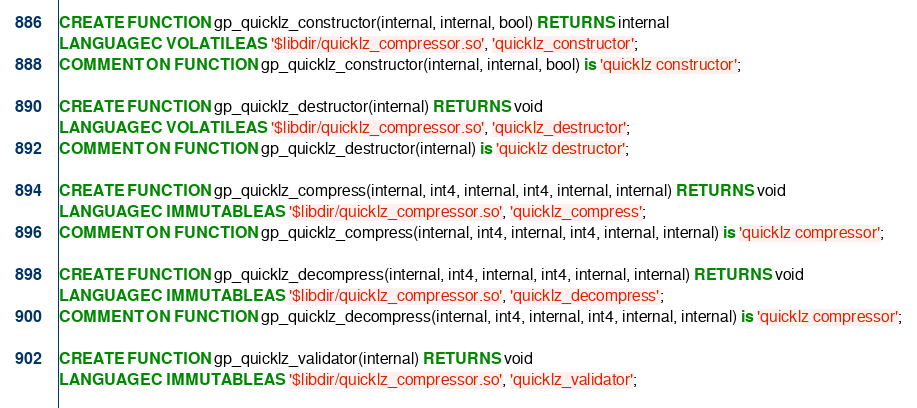Convert code to text. <code><loc_0><loc_0><loc_500><loc_500><_SQL_>CREATE FUNCTION gp_quicklz_constructor(internal, internal, bool) RETURNS internal
LANGUAGE C VOLATILE AS '$libdir/quicklz_compressor.so', 'quicklz_constructor';
COMMENT ON FUNCTION gp_quicklz_constructor(internal, internal, bool) is 'quicklz constructor';

CREATE FUNCTION gp_quicklz_destructor(internal) RETURNS void
LANGUAGE C VOLATILE AS '$libdir/quicklz_compressor.so', 'quicklz_destructor';
COMMENT ON FUNCTION gp_quicklz_destructor(internal) is 'quicklz destructor';

CREATE FUNCTION gp_quicklz_compress(internal, int4, internal, int4, internal, internal) RETURNS void
LANGUAGE C IMMUTABLE AS '$libdir/quicklz_compressor.so', 'quicklz_compress';
COMMENT ON FUNCTION gp_quicklz_compress(internal, int4, internal, int4, internal, internal) is 'quicklz compressor';

CREATE FUNCTION gp_quicklz_decompress(internal, int4, internal, int4, internal, internal) RETURNS void
LANGUAGE C IMMUTABLE AS '$libdir/quicklz_compressor.so', 'quicklz_decompress';
COMMENT ON FUNCTION gp_quicklz_decompress(internal, int4, internal, int4, internal, internal) is 'quicklz compressor';

CREATE FUNCTION gp_quicklz_validator(internal) RETURNS void
LANGUAGE C IMMUTABLE AS '$libdir/quicklz_compressor.so', 'quicklz_validator';</code> 